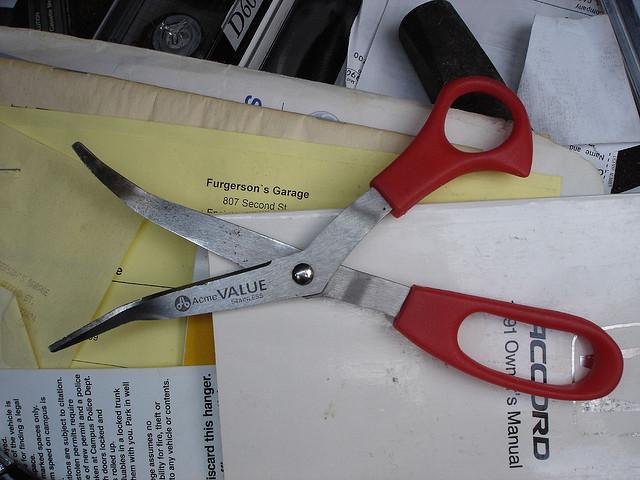What color are the handles of the scissors?
Answer briefly. Red. Do the scissors have a red handle?
Be succinct. Yes. Are the scissors stainless?
Answer briefly. Yes. What is printed on the left piece of paper?
Answer briefly. Furgerson's garage. Which writing is handwritten?
Short answer required. None. What is the five-letter word in bold on the scissors?
Concise answer only. Value. What hand scissors are these?
Give a very brief answer. Right. What do you call this kind of knife?
Concise answer only. Scissors. What color is the scissor handle?
Concise answer only. Red. What were the scissors used for?
Keep it brief. Cutting. What is the address of Furgerson's Garage?
Short answer required. 807 second st. 